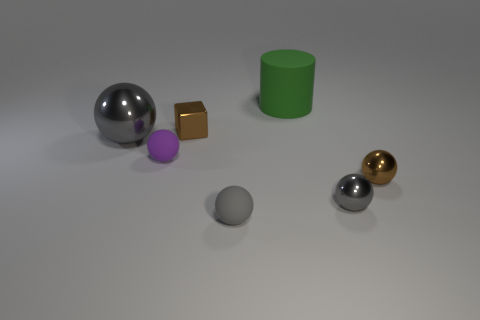What color is the tiny block?
Make the answer very short. Brown. There is a brown thing behind the small brown metal thing to the right of the big green rubber thing that is behind the big gray shiny ball; what size is it?
Provide a succinct answer. Small. What number of other things are there of the same shape as the small purple object?
Keep it short and to the point. 4. There is a matte object that is both behind the tiny brown sphere and to the right of the metal block; what color is it?
Offer a very short reply. Green. There is a thing that is to the right of the tiny gray metal ball; is it the same color as the metal cube?
Provide a short and direct response. Yes. How many balls are big metal things or purple things?
Offer a very short reply. 2. There is a tiny gray thing in front of the small gray metal ball; what shape is it?
Provide a succinct answer. Sphere. What is the color of the matte object behind the gray metallic ball on the left side of the brown metallic thing that is on the left side of the large green thing?
Ensure brevity in your answer.  Green. Does the small brown ball have the same material as the block?
Ensure brevity in your answer.  Yes. How many brown things are big matte cylinders or balls?
Offer a terse response. 1. 